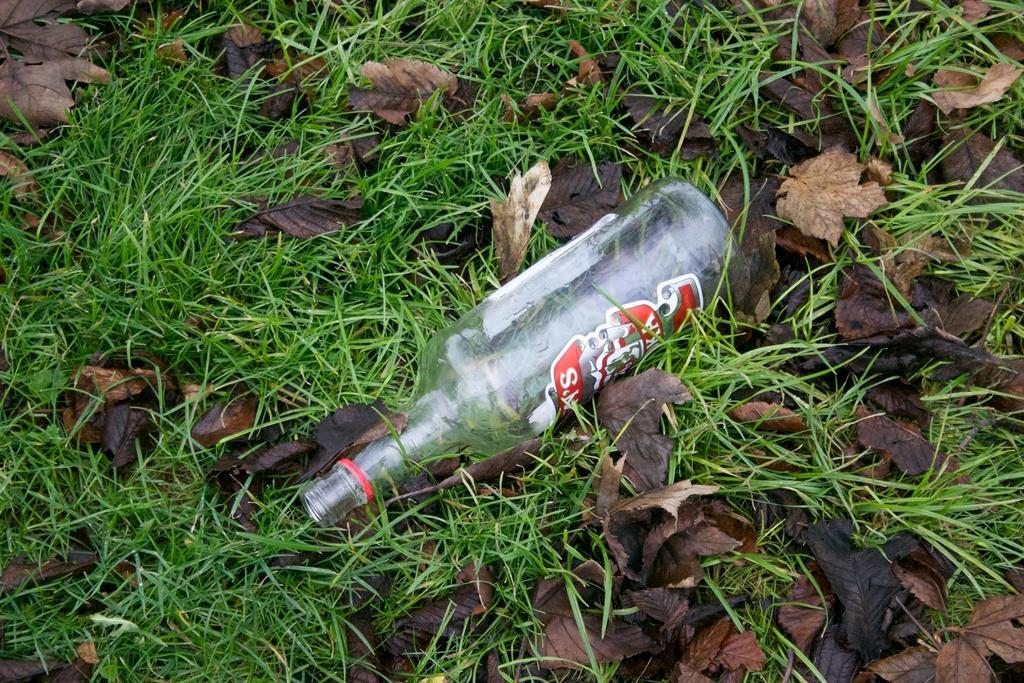In one or two sentences, can you explain what this image depicts? In the given image we can see a water bottle lying on grass. These are dry leaves. 